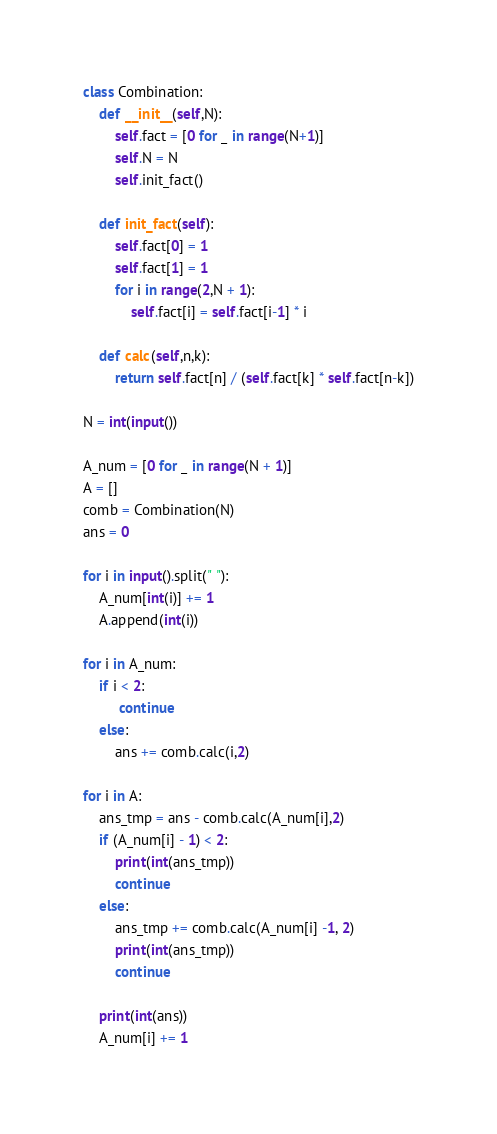<code> <loc_0><loc_0><loc_500><loc_500><_Python_>class Combination:
    def __init__(self,N):
        self.fact = [0 for _ in range(N+1)]
        self.N = N
        self.init_fact()
    
    def init_fact(self):
        self.fact[0] = 1
        self.fact[1] = 1
        for i in range(2,N + 1):
            self.fact[i] = self.fact[i-1] * i

    def calc(self,n,k):
        return self.fact[n] / (self.fact[k] * self.fact[n-k])

N = int(input())

A_num = [0 for _ in range(N + 1)]
A = []
comb = Combination(N)
ans = 0

for i in input().split(" "):
    A_num[int(i)] += 1
    A.append(int(i))

for i in A_num:
    if i < 2:
         continue
    else:
        ans += comb.calc(i,2)

for i in A:
    ans_tmp = ans - comb.calc(A_num[i],2)
    if (A_num[i] - 1) < 2:
        print(int(ans_tmp))
        continue
    else:
        ans_tmp += comb.calc(A_num[i] -1, 2)
        print(int(ans_tmp))
        continue

    print(int(ans))
    A_num[i] += 1</code> 